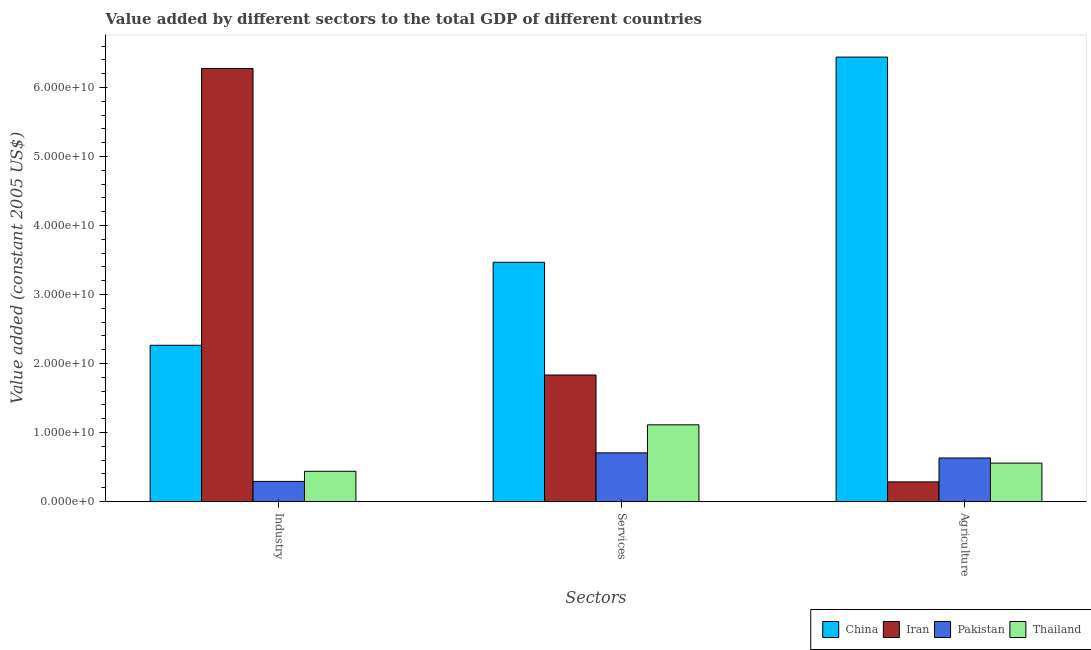How many different coloured bars are there?
Your answer should be compact. 4. How many groups of bars are there?
Provide a succinct answer. 3. Are the number of bars per tick equal to the number of legend labels?
Offer a very short reply. Yes. Are the number of bars on each tick of the X-axis equal?
Provide a succinct answer. Yes. What is the label of the 1st group of bars from the left?
Offer a very short reply. Industry. What is the value added by industrial sector in China?
Ensure brevity in your answer.  2.26e+1. Across all countries, what is the maximum value added by agricultural sector?
Make the answer very short. 6.44e+1. Across all countries, what is the minimum value added by agricultural sector?
Provide a succinct answer. 2.85e+09. In which country was the value added by industrial sector maximum?
Offer a very short reply. Iran. In which country was the value added by agricultural sector minimum?
Your answer should be compact. Iran. What is the total value added by agricultural sector in the graph?
Your answer should be compact. 7.92e+1. What is the difference between the value added by agricultural sector in Pakistan and that in Iran?
Give a very brief answer. 3.46e+09. What is the difference between the value added by agricultural sector in China and the value added by services in Thailand?
Provide a succinct answer. 5.33e+1. What is the average value added by agricultural sector per country?
Make the answer very short. 1.98e+1. What is the difference between the value added by industrial sector and value added by agricultural sector in Pakistan?
Keep it short and to the point. -3.40e+09. What is the ratio of the value added by agricultural sector in China to that in Iran?
Provide a short and direct response. 22.58. Is the difference between the value added by services in Pakistan and Thailand greater than the difference between the value added by industrial sector in Pakistan and Thailand?
Your answer should be compact. No. What is the difference between the highest and the second highest value added by industrial sector?
Keep it short and to the point. 4.01e+1. What is the difference between the highest and the lowest value added by agricultural sector?
Your answer should be compact. 6.16e+1. Is the sum of the value added by agricultural sector in Iran and Pakistan greater than the maximum value added by services across all countries?
Ensure brevity in your answer.  No. What does the 2nd bar from the left in Agriculture represents?
Your response must be concise. Iran. What does the 3rd bar from the right in Services represents?
Your response must be concise. Iran. Are all the bars in the graph horizontal?
Ensure brevity in your answer.  No. What is the difference between two consecutive major ticks on the Y-axis?
Your answer should be very brief. 1.00e+1. Does the graph contain grids?
Give a very brief answer. No. How many legend labels are there?
Make the answer very short. 4. How are the legend labels stacked?
Give a very brief answer. Horizontal. What is the title of the graph?
Your answer should be compact. Value added by different sectors to the total GDP of different countries. What is the label or title of the X-axis?
Your answer should be very brief. Sectors. What is the label or title of the Y-axis?
Provide a short and direct response. Value added (constant 2005 US$). What is the Value added (constant 2005 US$) in China in Industry?
Offer a terse response. 2.26e+1. What is the Value added (constant 2005 US$) of Iran in Industry?
Give a very brief answer. 6.28e+1. What is the Value added (constant 2005 US$) of Pakistan in Industry?
Provide a succinct answer. 2.92e+09. What is the Value added (constant 2005 US$) of Thailand in Industry?
Make the answer very short. 4.39e+09. What is the Value added (constant 2005 US$) of China in Services?
Ensure brevity in your answer.  3.47e+1. What is the Value added (constant 2005 US$) of Iran in Services?
Keep it short and to the point. 1.83e+1. What is the Value added (constant 2005 US$) of Pakistan in Services?
Your answer should be very brief. 7.06e+09. What is the Value added (constant 2005 US$) in Thailand in Services?
Keep it short and to the point. 1.11e+1. What is the Value added (constant 2005 US$) of China in Agriculture?
Offer a terse response. 6.44e+1. What is the Value added (constant 2005 US$) in Iran in Agriculture?
Offer a terse response. 2.85e+09. What is the Value added (constant 2005 US$) in Pakistan in Agriculture?
Provide a succinct answer. 6.32e+09. What is the Value added (constant 2005 US$) in Thailand in Agriculture?
Offer a very short reply. 5.57e+09. Across all Sectors, what is the maximum Value added (constant 2005 US$) of China?
Offer a terse response. 6.44e+1. Across all Sectors, what is the maximum Value added (constant 2005 US$) of Iran?
Offer a very short reply. 6.28e+1. Across all Sectors, what is the maximum Value added (constant 2005 US$) of Pakistan?
Your response must be concise. 7.06e+09. Across all Sectors, what is the maximum Value added (constant 2005 US$) of Thailand?
Provide a succinct answer. 1.11e+1. Across all Sectors, what is the minimum Value added (constant 2005 US$) in China?
Your response must be concise. 2.26e+1. Across all Sectors, what is the minimum Value added (constant 2005 US$) of Iran?
Offer a very short reply. 2.85e+09. Across all Sectors, what is the minimum Value added (constant 2005 US$) in Pakistan?
Offer a terse response. 2.92e+09. Across all Sectors, what is the minimum Value added (constant 2005 US$) in Thailand?
Your answer should be compact. 4.39e+09. What is the total Value added (constant 2005 US$) in China in the graph?
Give a very brief answer. 1.22e+11. What is the total Value added (constant 2005 US$) of Iran in the graph?
Give a very brief answer. 8.39e+1. What is the total Value added (constant 2005 US$) in Pakistan in the graph?
Your response must be concise. 1.63e+1. What is the total Value added (constant 2005 US$) in Thailand in the graph?
Make the answer very short. 2.11e+1. What is the difference between the Value added (constant 2005 US$) in China in Industry and that in Services?
Provide a short and direct response. -1.20e+1. What is the difference between the Value added (constant 2005 US$) in Iran in Industry and that in Services?
Your response must be concise. 4.44e+1. What is the difference between the Value added (constant 2005 US$) of Pakistan in Industry and that in Services?
Keep it short and to the point. -4.14e+09. What is the difference between the Value added (constant 2005 US$) of Thailand in Industry and that in Services?
Offer a very short reply. -6.74e+09. What is the difference between the Value added (constant 2005 US$) of China in Industry and that in Agriculture?
Offer a very short reply. -4.18e+1. What is the difference between the Value added (constant 2005 US$) of Iran in Industry and that in Agriculture?
Provide a short and direct response. 5.99e+1. What is the difference between the Value added (constant 2005 US$) in Pakistan in Industry and that in Agriculture?
Provide a succinct answer. -3.40e+09. What is the difference between the Value added (constant 2005 US$) in Thailand in Industry and that in Agriculture?
Keep it short and to the point. -1.19e+09. What is the difference between the Value added (constant 2005 US$) of China in Services and that in Agriculture?
Your response must be concise. -2.97e+1. What is the difference between the Value added (constant 2005 US$) in Iran in Services and that in Agriculture?
Offer a very short reply. 1.55e+1. What is the difference between the Value added (constant 2005 US$) of Pakistan in Services and that in Agriculture?
Your answer should be compact. 7.40e+08. What is the difference between the Value added (constant 2005 US$) of Thailand in Services and that in Agriculture?
Ensure brevity in your answer.  5.55e+09. What is the difference between the Value added (constant 2005 US$) of China in Industry and the Value added (constant 2005 US$) of Iran in Services?
Offer a terse response. 4.31e+09. What is the difference between the Value added (constant 2005 US$) of China in Industry and the Value added (constant 2005 US$) of Pakistan in Services?
Offer a very short reply. 1.56e+1. What is the difference between the Value added (constant 2005 US$) of China in Industry and the Value added (constant 2005 US$) of Thailand in Services?
Your response must be concise. 1.15e+1. What is the difference between the Value added (constant 2005 US$) in Iran in Industry and the Value added (constant 2005 US$) in Pakistan in Services?
Provide a short and direct response. 5.57e+1. What is the difference between the Value added (constant 2005 US$) of Iran in Industry and the Value added (constant 2005 US$) of Thailand in Services?
Your answer should be very brief. 5.16e+1. What is the difference between the Value added (constant 2005 US$) in Pakistan in Industry and the Value added (constant 2005 US$) in Thailand in Services?
Your answer should be very brief. -8.20e+09. What is the difference between the Value added (constant 2005 US$) in China in Industry and the Value added (constant 2005 US$) in Iran in Agriculture?
Your answer should be compact. 1.98e+1. What is the difference between the Value added (constant 2005 US$) in China in Industry and the Value added (constant 2005 US$) in Pakistan in Agriculture?
Make the answer very short. 1.63e+1. What is the difference between the Value added (constant 2005 US$) of China in Industry and the Value added (constant 2005 US$) of Thailand in Agriculture?
Provide a succinct answer. 1.71e+1. What is the difference between the Value added (constant 2005 US$) of Iran in Industry and the Value added (constant 2005 US$) of Pakistan in Agriculture?
Your answer should be compact. 5.64e+1. What is the difference between the Value added (constant 2005 US$) of Iran in Industry and the Value added (constant 2005 US$) of Thailand in Agriculture?
Make the answer very short. 5.72e+1. What is the difference between the Value added (constant 2005 US$) in Pakistan in Industry and the Value added (constant 2005 US$) in Thailand in Agriculture?
Your answer should be compact. -2.65e+09. What is the difference between the Value added (constant 2005 US$) of China in Services and the Value added (constant 2005 US$) of Iran in Agriculture?
Keep it short and to the point. 3.18e+1. What is the difference between the Value added (constant 2005 US$) in China in Services and the Value added (constant 2005 US$) in Pakistan in Agriculture?
Keep it short and to the point. 2.84e+1. What is the difference between the Value added (constant 2005 US$) in China in Services and the Value added (constant 2005 US$) in Thailand in Agriculture?
Keep it short and to the point. 2.91e+1. What is the difference between the Value added (constant 2005 US$) in Iran in Services and the Value added (constant 2005 US$) in Pakistan in Agriculture?
Offer a very short reply. 1.20e+1. What is the difference between the Value added (constant 2005 US$) in Iran in Services and the Value added (constant 2005 US$) in Thailand in Agriculture?
Your answer should be very brief. 1.28e+1. What is the difference between the Value added (constant 2005 US$) in Pakistan in Services and the Value added (constant 2005 US$) in Thailand in Agriculture?
Offer a very short reply. 1.48e+09. What is the average Value added (constant 2005 US$) in China per Sectors?
Your response must be concise. 4.06e+1. What is the average Value added (constant 2005 US$) in Iran per Sectors?
Provide a short and direct response. 2.80e+1. What is the average Value added (constant 2005 US$) of Pakistan per Sectors?
Your response must be concise. 5.43e+09. What is the average Value added (constant 2005 US$) of Thailand per Sectors?
Your answer should be compact. 7.03e+09. What is the difference between the Value added (constant 2005 US$) of China and Value added (constant 2005 US$) of Iran in Industry?
Your answer should be compact. -4.01e+1. What is the difference between the Value added (constant 2005 US$) of China and Value added (constant 2005 US$) of Pakistan in Industry?
Your answer should be compact. 1.97e+1. What is the difference between the Value added (constant 2005 US$) in China and Value added (constant 2005 US$) in Thailand in Industry?
Your answer should be compact. 1.83e+1. What is the difference between the Value added (constant 2005 US$) in Iran and Value added (constant 2005 US$) in Pakistan in Industry?
Ensure brevity in your answer.  5.98e+1. What is the difference between the Value added (constant 2005 US$) of Iran and Value added (constant 2005 US$) of Thailand in Industry?
Ensure brevity in your answer.  5.84e+1. What is the difference between the Value added (constant 2005 US$) of Pakistan and Value added (constant 2005 US$) of Thailand in Industry?
Your answer should be compact. -1.47e+09. What is the difference between the Value added (constant 2005 US$) in China and Value added (constant 2005 US$) in Iran in Services?
Offer a very short reply. 1.63e+1. What is the difference between the Value added (constant 2005 US$) of China and Value added (constant 2005 US$) of Pakistan in Services?
Make the answer very short. 2.76e+1. What is the difference between the Value added (constant 2005 US$) in China and Value added (constant 2005 US$) in Thailand in Services?
Provide a short and direct response. 2.36e+1. What is the difference between the Value added (constant 2005 US$) of Iran and Value added (constant 2005 US$) of Pakistan in Services?
Your response must be concise. 1.13e+1. What is the difference between the Value added (constant 2005 US$) in Iran and Value added (constant 2005 US$) in Thailand in Services?
Provide a succinct answer. 7.22e+09. What is the difference between the Value added (constant 2005 US$) in Pakistan and Value added (constant 2005 US$) in Thailand in Services?
Give a very brief answer. -4.07e+09. What is the difference between the Value added (constant 2005 US$) in China and Value added (constant 2005 US$) in Iran in Agriculture?
Your answer should be very brief. 6.16e+1. What is the difference between the Value added (constant 2005 US$) of China and Value added (constant 2005 US$) of Pakistan in Agriculture?
Provide a succinct answer. 5.81e+1. What is the difference between the Value added (constant 2005 US$) in China and Value added (constant 2005 US$) in Thailand in Agriculture?
Your answer should be compact. 5.88e+1. What is the difference between the Value added (constant 2005 US$) of Iran and Value added (constant 2005 US$) of Pakistan in Agriculture?
Make the answer very short. -3.46e+09. What is the difference between the Value added (constant 2005 US$) in Iran and Value added (constant 2005 US$) in Thailand in Agriculture?
Make the answer very short. -2.72e+09. What is the difference between the Value added (constant 2005 US$) in Pakistan and Value added (constant 2005 US$) in Thailand in Agriculture?
Give a very brief answer. 7.43e+08. What is the ratio of the Value added (constant 2005 US$) in China in Industry to that in Services?
Your answer should be very brief. 0.65. What is the ratio of the Value added (constant 2005 US$) in Iran in Industry to that in Services?
Keep it short and to the point. 3.42. What is the ratio of the Value added (constant 2005 US$) in Pakistan in Industry to that in Services?
Make the answer very short. 0.41. What is the ratio of the Value added (constant 2005 US$) of Thailand in Industry to that in Services?
Your answer should be compact. 0.39. What is the ratio of the Value added (constant 2005 US$) of China in Industry to that in Agriculture?
Give a very brief answer. 0.35. What is the ratio of the Value added (constant 2005 US$) in Iran in Industry to that in Agriculture?
Offer a terse response. 22. What is the ratio of the Value added (constant 2005 US$) in Pakistan in Industry to that in Agriculture?
Provide a succinct answer. 0.46. What is the ratio of the Value added (constant 2005 US$) in Thailand in Industry to that in Agriculture?
Give a very brief answer. 0.79. What is the ratio of the Value added (constant 2005 US$) in China in Services to that in Agriculture?
Ensure brevity in your answer.  0.54. What is the ratio of the Value added (constant 2005 US$) of Iran in Services to that in Agriculture?
Offer a very short reply. 6.43. What is the ratio of the Value added (constant 2005 US$) of Pakistan in Services to that in Agriculture?
Ensure brevity in your answer.  1.12. What is the ratio of the Value added (constant 2005 US$) of Thailand in Services to that in Agriculture?
Your answer should be very brief. 2. What is the difference between the highest and the second highest Value added (constant 2005 US$) in China?
Keep it short and to the point. 2.97e+1. What is the difference between the highest and the second highest Value added (constant 2005 US$) in Iran?
Offer a terse response. 4.44e+1. What is the difference between the highest and the second highest Value added (constant 2005 US$) of Pakistan?
Give a very brief answer. 7.40e+08. What is the difference between the highest and the second highest Value added (constant 2005 US$) of Thailand?
Provide a succinct answer. 5.55e+09. What is the difference between the highest and the lowest Value added (constant 2005 US$) in China?
Make the answer very short. 4.18e+1. What is the difference between the highest and the lowest Value added (constant 2005 US$) of Iran?
Your answer should be very brief. 5.99e+1. What is the difference between the highest and the lowest Value added (constant 2005 US$) in Pakistan?
Make the answer very short. 4.14e+09. What is the difference between the highest and the lowest Value added (constant 2005 US$) of Thailand?
Make the answer very short. 6.74e+09. 